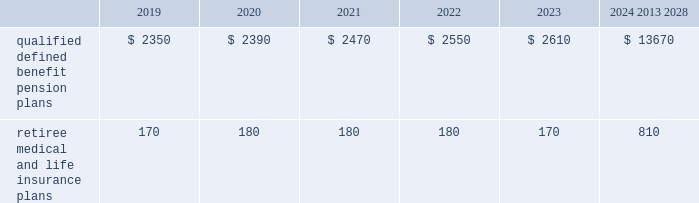Valuation techniques 2013 cash equivalents are mostly comprised of short-term money-market instruments and are valued at cost , which approximates fair value .
U.s .
Equity securities and international equity securities categorized as level 1 are traded on active national and international exchanges and are valued at their closing prices on the last trading day of the year .
For u.s .
Equity securities and international equity securities not traded on an active exchange , or if the closing price is not available , the trustee obtains indicative quotes from a pricing vendor , broker or investment manager .
These securities are categorized as level 2 if the custodian obtains corroborated quotes from a pricing vendor or categorized as level 3 if the custodian obtains uncorroborated quotes from a broker or investment manager .
Commingled equity funds categorized as level 1 are traded on active national and international exchanges and are valued at their closing prices on the last trading day of the year .
For commingled equity funds not traded on an active exchange , or if the closing price is not available , the trustee obtains indicative quotes from a pricing vendor , broker or investment manager .
These securities are categorized as level 2 if the custodian obtains corroborated quotes from a pricing vendor .
Fixed income investments categorized as level 2 are valued by the trustee using pricing models that use verifiable observable market data ( e.g. , interest rates and yield curves observable at commonly quoted intervals and credit spreads ) , bids provided by brokers or dealers or quoted prices of securities with similar characteristics .
Fixed income investments are categorized as level 3 when valuations using observable inputs are unavailable .
The trustee typically obtains pricing based on indicative quotes or bid evaluations from vendors , brokers or the investment manager .
In addition , certain other fixed income investments categorized as level 3 are valued using a discounted cash flow approach .
Significant inputs include projected annuity payments and the discount rate applied to those payments .
Certain commingled equity funds , consisting of equity mutual funds , are valued using the nav .
The nav valuations are based on the underlying investments and typically redeemable within 90 days .
Private equity funds consist of partnership and co-investment funds .
The nav is based on valuation models of the underlying securities , which includes unobservable inputs that cannot be corroborated using verifiable observable market data .
These funds typically have redemption periods between eight and 12 years .
Real estate funds consist of partnerships , most of which are closed-end funds , for which the nav is based on valuation models and periodic appraisals .
These funds typically have redemption periods between eight and 10 years .
Hedge funds consist of direct hedge funds for which the nav is generally based on the valuation of the underlying investments .
Redemptions in hedge funds are based on the specific terms of each fund , and generally range from a minimum of one month to several months .
Contributions and expected benefit payments the funding of our qualified defined benefit pension plans is determined in accordance with erisa , as amended by the ppa , and in a manner consistent with cas and internal revenue code rules .
We made contributions of $ 5.0 billion to our qualified defined benefit pension plans in 2018 , including required and discretionary contributions .
As a result of these contributions , we do not expect to make contributions to our qualified defined benefit pension plans in 2019 .
The table presents estimated future benefit payments , which reflect expected future employee service , as of december 31 , 2018 ( in millions ) : .
Defined contribution plans we maintain a number of defined contribution plans , most with 401 ( k ) features , that cover substantially all of our employees .
Under the provisions of our 401 ( k ) plans , we match most employees 2019 eligible contributions at rates specified in the plan documents .
Our contributions were $ 658 million in 2018 , $ 613 million in 2017 and $ 617 million in 2016 , the majority of which were funded using our common stock .
Our defined contribution plans held approximately 33.3 million and 35.5 million shares of our common stock as of december 31 , 2018 and 2017. .
What was the percentage of the change in the employee matching contributions from 2017 to 2018? 
Computations: ((658 - 613) / 613)
Answer: 0.07341. 